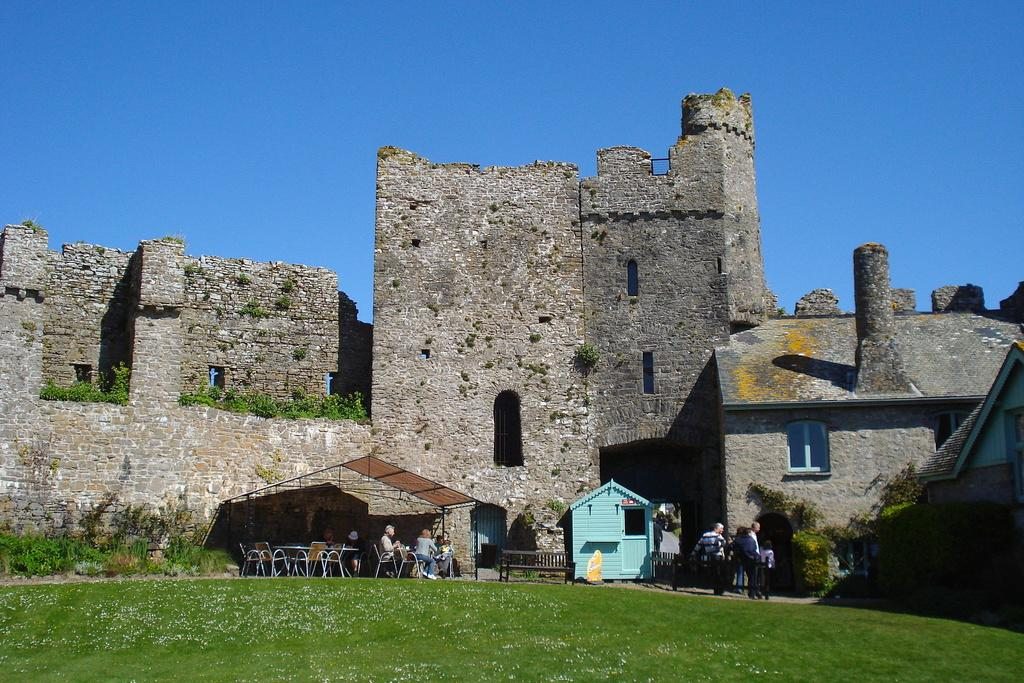What type of outdoor space is depicted in the image? There is a garden in the image. What can be seen in the background of the garden? There are chairs in the background of the image. Are there any people in the image? Yes, there are people sitting on the chairs. What structure is present in the image? There is a fort in the image. What is the color of the sky in the image? The sky is blue in the image. Can you tell me what the argument between the two people sitting on the chairs is about? There is no argument depicted in the image; it only shows people sitting on chairs in a garden. How many persons are downtown in the image? The term "downtown" is not mentioned in the image, and there is no indication of a downtown area being present. 